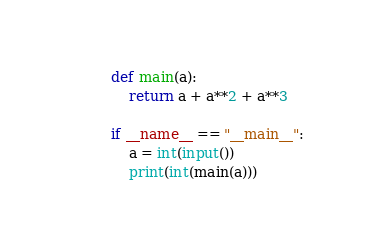Convert code to text. <code><loc_0><loc_0><loc_500><loc_500><_Python_>def main(a):
    return a + a**2 + a**3

if __name__ == "__main__":
    a = int(input())
    print(int(main(a)))
</code> 